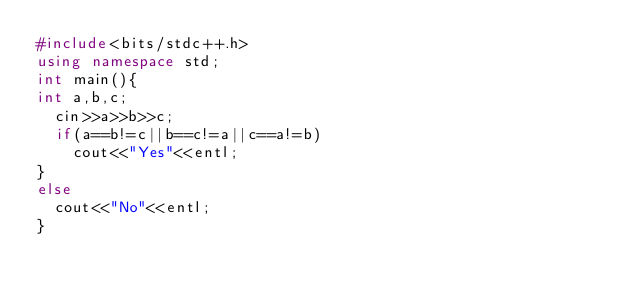Convert code to text. <code><loc_0><loc_0><loc_500><loc_500><_C++_>#include<bits/stdc++.h>
using namespace std;
int main(){
int a,b,c;
  cin>>a>>b>>c;
  if(a==b!=c||b==c!=a||c==a!=b)
    cout<<"Yes"<<entl;
}
else
  cout<<"No"<<entl;
}
</code> 